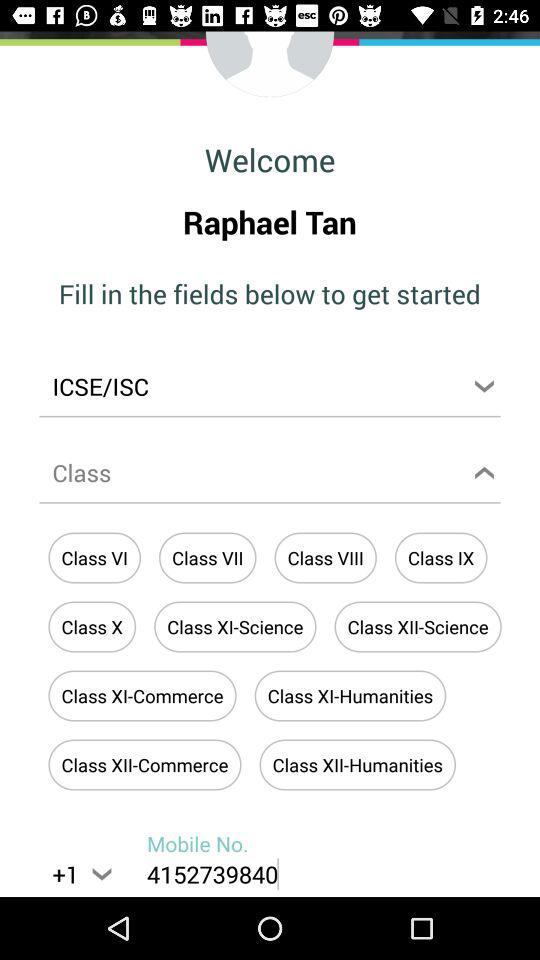How many digits are there in the phone number?
Answer the question using a single word or phrase. 10 